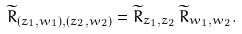<formula> <loc_0><loc_0><loc_500><loc_500>\widetilde { R } _ { ( z _ { 1 } , w _ { 1 } ) , ( z _ { 2 } , w _ { 2 } ) } = \widetilde { R } _ { z _ { 1 } , z _ { 2 } } \, \widetilde { R } _ { w _ { 1 } , w _ { 2 } } .</formula> 